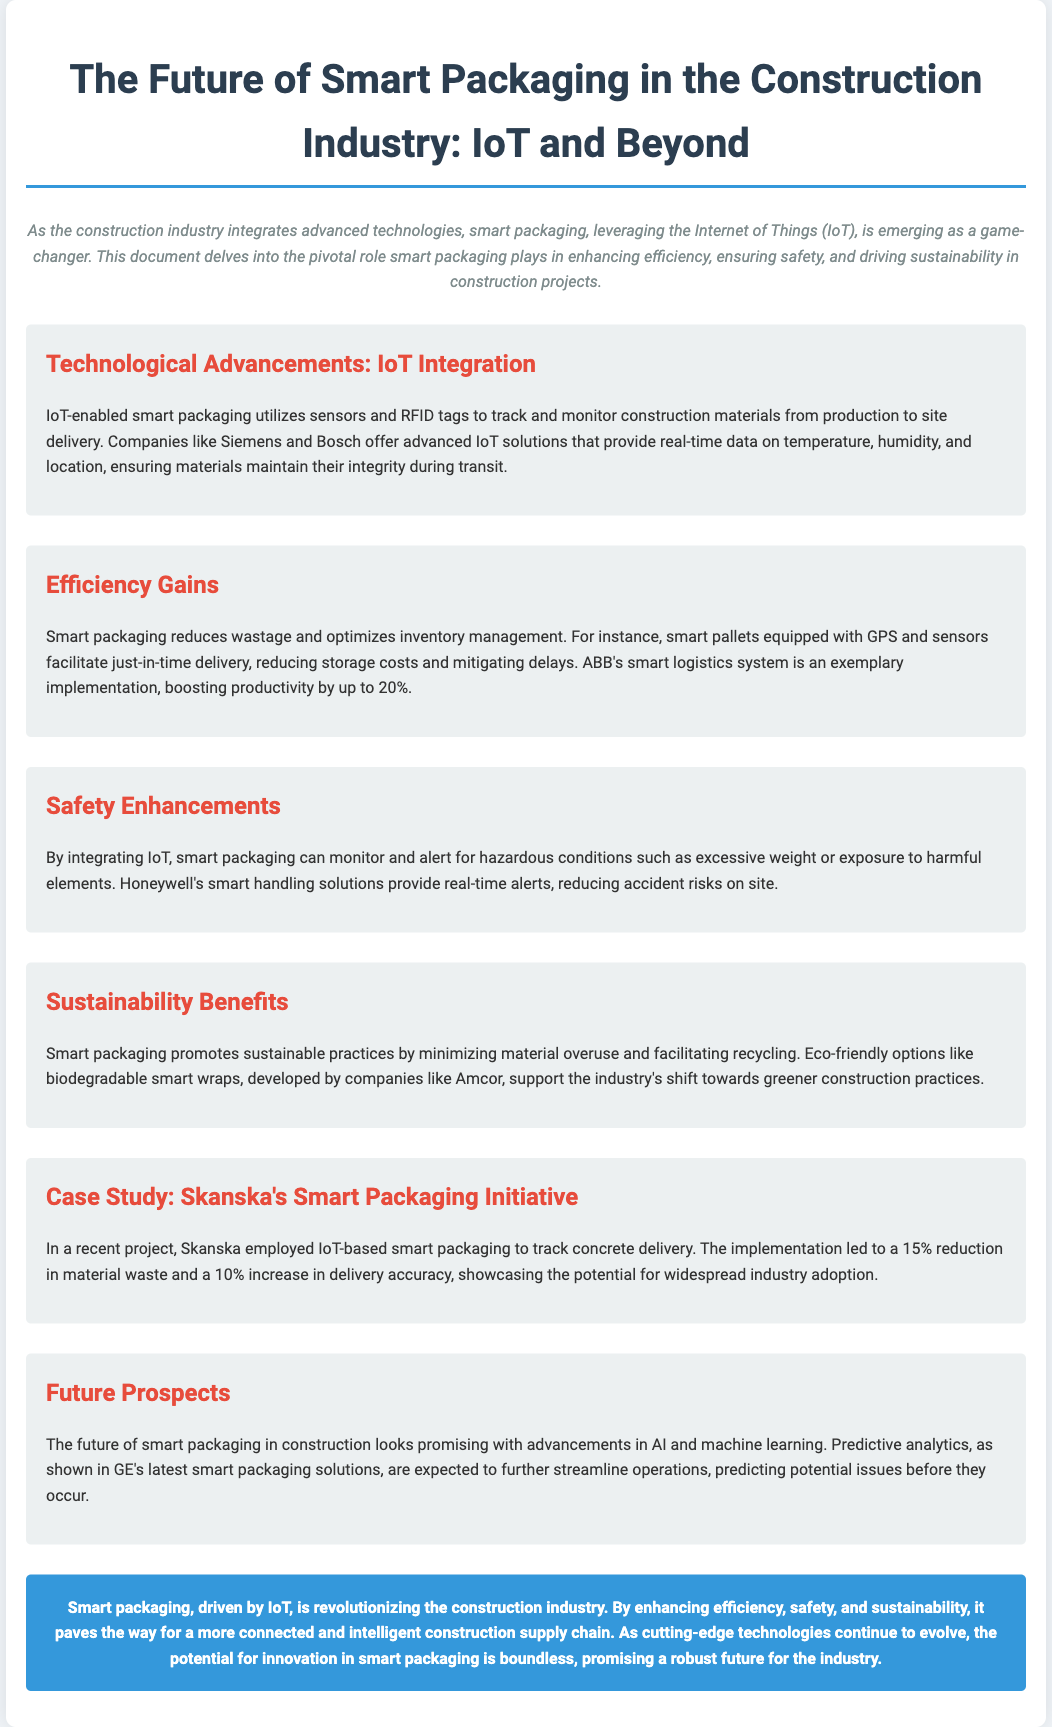What is the title of the document? The title of the document is stated in the header section, summarizing the main topic covered.
Answer: The Future of Smart Packaging in the Construction Industry: IoT and Beyond Which companies are mentioned as offering IoT solutions? The document lists Siemens and Bosch as companies providing advanced IoT solutions in smart packaging.
Answer: Siemens and Bosch What percentage productivity boost does ABB's smart logistics system achieve? The document specifies that ABB's smart logistics system boosts productivity by 20%.
Answer: 20% What hazardous conditions can smart packaging monitor? The document mentions that smart packaging can monitor conditions such as excessive weight or exposure to harmful elements.
Answer: Excessive weight or exposure to harmful elements What was the reduction in material waste reported by Skanska's initiative? The document provides that Skanska's initiative led to a 15% reduction in material waste.
Answer: 15% What type of eco-friendly packaging option is developed by Amcor? The document highlights biodegradable smart wraps as an eco-friendly packaging option developed by Amcor.
Answer: Biodegradable smart wraps Which advanced technologies are expected to enhance the future of smart packaging? The document suggests that AI and machine learning advancements will enhance smart packaging in the future.
Answer: AI and machine learning What is one key benefit of smart packaging in construction? The document outlines that one key benefit is enhancing efficiency in construction projects.
Answer: Enhancing efficiency 